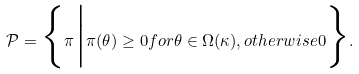<formula> <loc_0><loc_0><loc_500><loc_500>\mathcal { P } = \Big \{ \pi \Big | \pi ( \theta ) \geq 0 f o r \theta \in \Omega ( \kappa ) , o t h e r w i s e 0 \Big \} .</formula> 